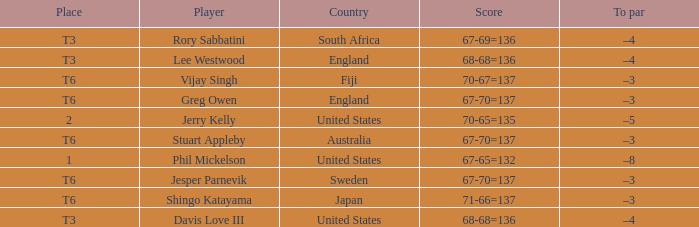Name the place for score of 67-70=137 and stuart appleby T6. 